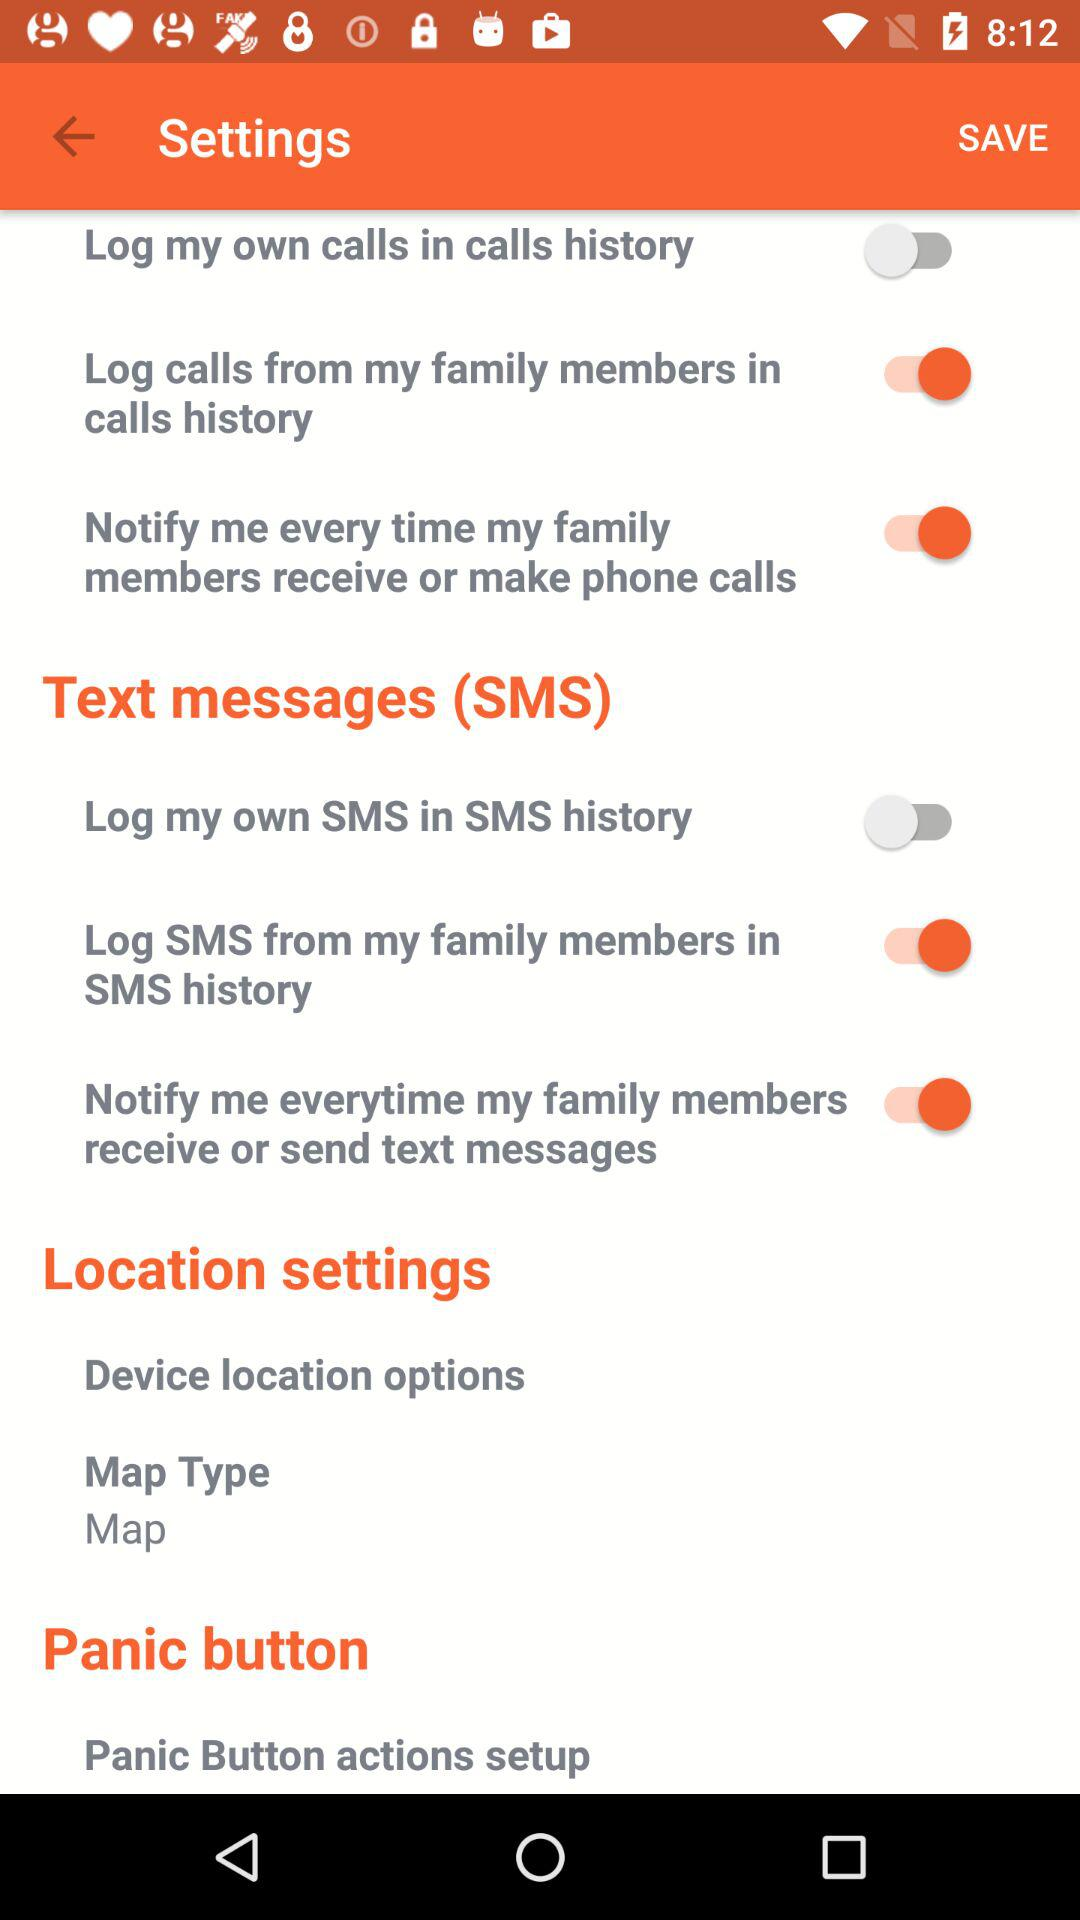What is the status of "Log my own SMS in SMS history"? The status is "off". 